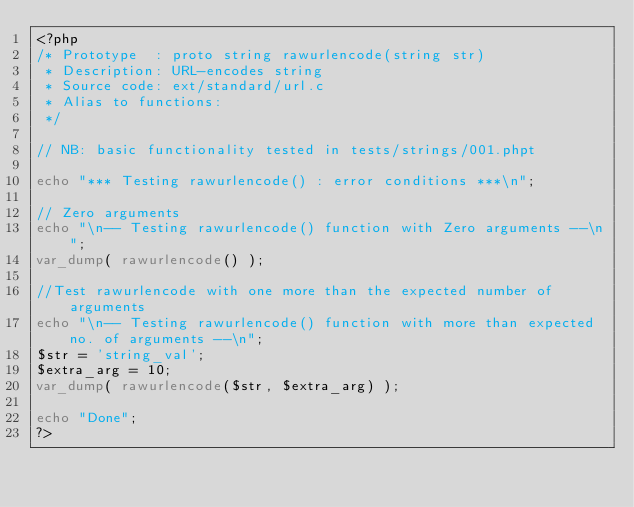<code> <loc_0><loc_0><loc_500><loc_500><_PHP_><?php
/* Prototype  : proto string rawurlencode(string str)
 * Description: URL-encodes string 
 * Source code: ext/standard/url.c
 * Alias to functions: 
 */

// NB: basic functionality tested in tests/strings/001.phpt

echo "*** Testing rawurlencode() : error conditions ***\n";

// Zero arguments
echo "\n-- Testing rawurlencode() function with Zero arguments --\n";
var_dump( rawurlencode() );

//Test rawurlencode with one more than the expected number of arguments
echo "\n-- Testing rawurlencode() function with more than expected no. of arguments --\n";
$str = 'string_val';
$extra_arg = 10;
var_dump( rawurlencode($str, $extra_arg) );

echo "Done";
?></code> 